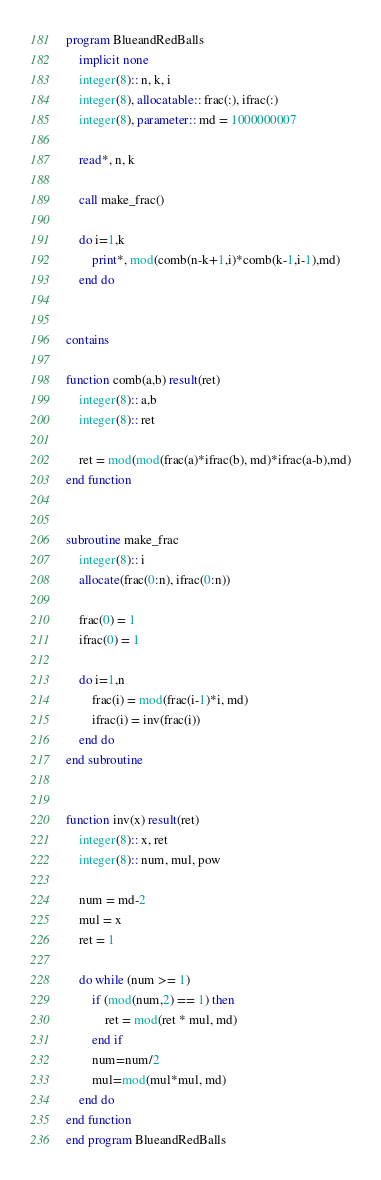Convert code to text. <code><loc_0><loc_0><loc_500><loc_500><_FORTRAN_>program BlueandRedBalls
    implicit none
    integer(8):: n, k, i
    integer(8), allocatable:: frac(:), ifrac(:)
    integer(8), parameter:: md = 1000000007

    read*, n, k

    call make_frac()

    do i=1,k
        print*, mod(comb(n-k+1,i)*comb(k-1,i-1),md)
    end do


contains

function comb(a,b) result(ret)
    integer(8):: a,b
    integer(8):: ret

    ret = mod(mod(frac(a)*ifrac(b), md)*ifrac(a-b),md)
end function


subroutine make_frac
    integer(8):: i
    allocate(frac(0:n), ifrac(0:n))

    frac(0) = 1
    ifrac(0) = 1

    do i=1,n
        frac(i) = mod(frac(i-1)*i, md)
        ifrac(i) = inv(frac(i))
    end do
end subroutine


function inv(x) result(ret)
    integer(8):: x, ret
    integer(8):: num, mul, pow

    num = md-2
    mul = x
    ret = 1

    do while (num >= 1)
        if (mod(num,2) == 1) then
            ret = mod(ret * mul, md)
        end if
        num=num/2
        mul=mod(mul*mul, md)
    end do
end function
end program BlueandRedBalls</code> 